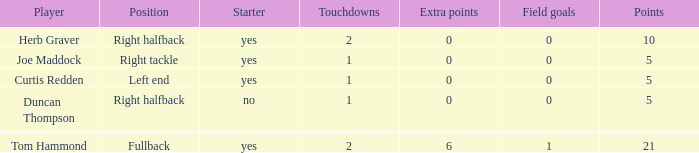Name the number of points for field goals being 1 1.0. 